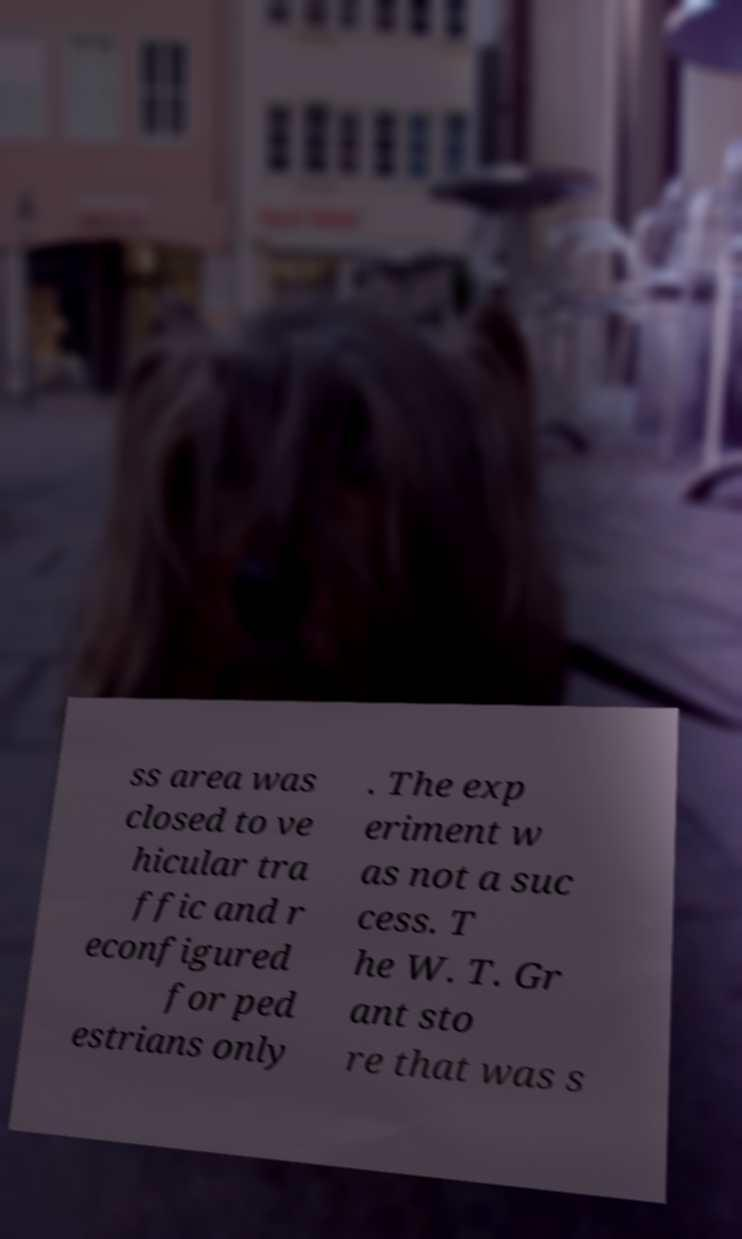Could you extract and type out the text from this image? ss area was closed to ve hicular tra ffic and r econfigured for ped estrians only . The exp eriment w as not a suc cess. T he W. T. Gr ant sto re that was s 